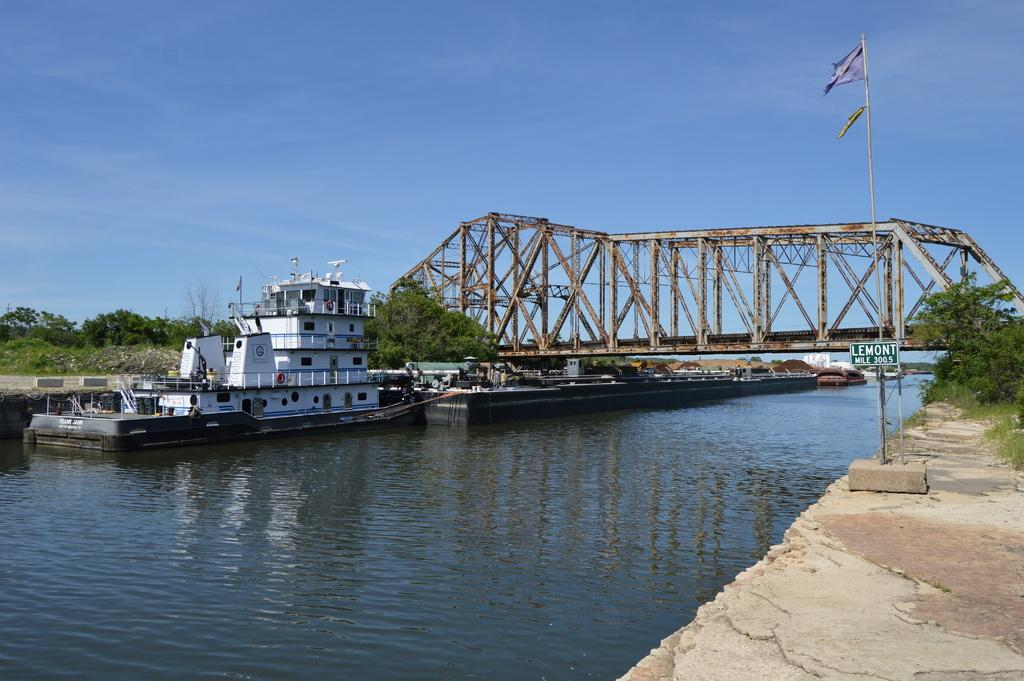What type of vehicles can be seen in the water in the image? There are boats in the water in the image. What structures are present in the image that hold flags? There are flag poles in the image. What type of barrier can be seen in the image? There is a fence in the image. What type of natural vegetation is present in the image? There are trees in the image. What type of structure can be seen crossing the water in the image? There is a bridge in the image. What type of man-made structures can be seen in the image? There are buildings in the image. What part of the natural environment is visible in the image? The sky is visible in the image. What type of location might the image depict? The image may have been taken near a lake. Where is the queen sitting in the carriage in the image? There is no queen or carriage present in the image. What type of station is visible in the image? There is no station present in the image. 